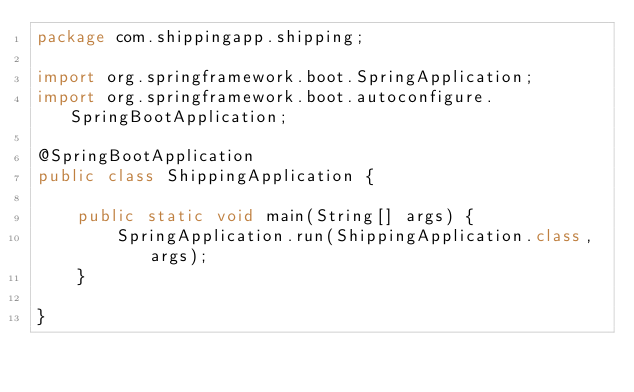<code> <loc_0><loc_0><loc_500><loc_500><_Java_>package com.shippingapp.shipping;

import org.springframework.boot.SpringApplication;
import org.springframework.boot.autoconfigure.SpringBootApplication;

@SpringBootApplication
public class ShippingApplication {

	public static void main(String[] args) {
		SpringApplication.run(ShippingApplication.class, args);
	}

}
</code> 